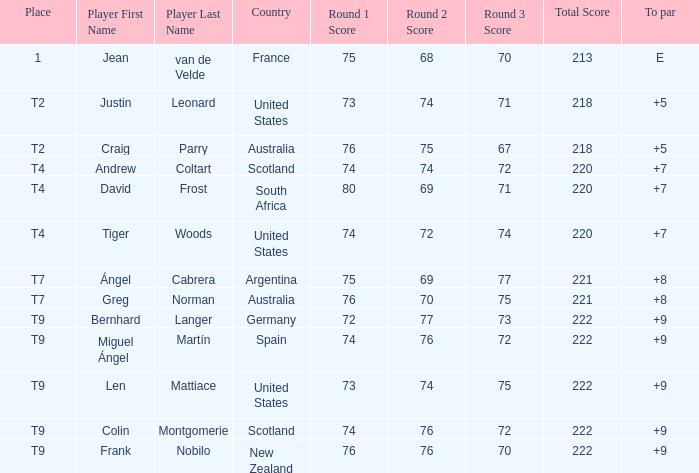In the game where david frost achieved a to par of +7, what was the ultimate score? 80-69-71=220. 